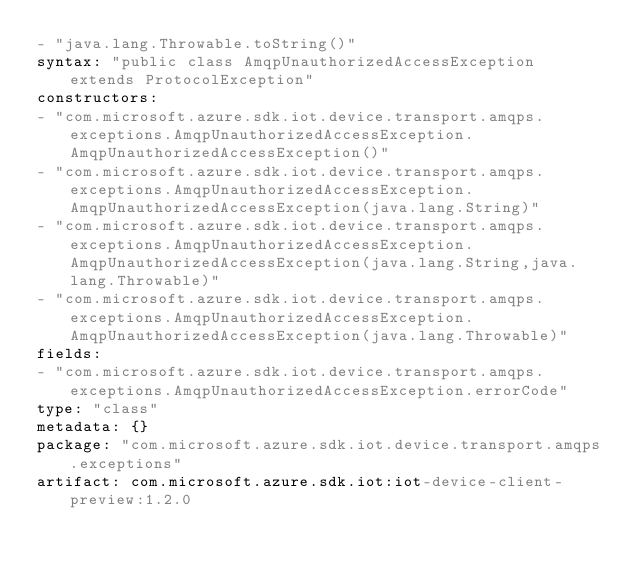Convert code to text. <code><loc_0><loc_0><loc_500><loc_500><_YAML_>- "java.lang.Throwable.toString()"
syntax: "public class AmqpUnauthorizedAccessException extends ProtocolException"
constructors:
- "com.microsoft.azure.sdk.iot.device.transport.amqps.exceptions.AmqpUnauthorizedAccessException.AmqpUnauthorizedAccessException()"
- "com.microsoft.azure.sdk.iot.device.transport.amqps.exceptions.AmqpUnauthorizedAccessException.AmqpUnauthorizedAccessException(java.lang.String)"
- "com.microsoft.azure.sdk.iot.device.transport.amqps.exceptions.AmqpUnauthorizedAccessException.AmqpUnauthorizedAccessException(java.lang.String,java.lang.Throwable)"
- "com.microsoft.azure.sdk.iot.device.transport.amqps.exceptions.AmqpUnauthorizedAccessException.AmqpUnauthorizedAccessException(java.lang.Throwable)"
fields:
- "com.microsoft.azure.sdk.iot.device.transport.amqps.exceptions.AmqpUnauthorizedAccessException.errorCode"
type: "class"
metadata: {}
package: "com.microsoft.azure.sdk.iot.device.transport.amqps.exceptions"
artifact: com.microsoft.azure.sdk.iot:iot-device-client-preview:1.2.0
</code> 